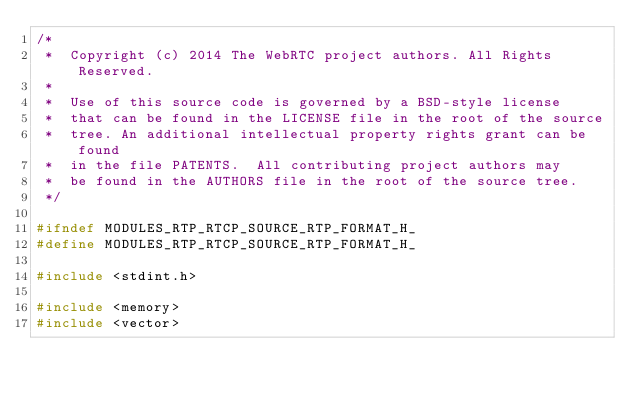<code> <loc_0><loc_0><loc_500><loc_500><_C_>/*
 *  Copyright (c) 2014 The WebRTC project authors. All Rights Reserved.
 *
 *  Use of this source code is governed by a BSD-style license
 *  that can be found in the LICENSE file in the root of the source
 *  tree. An additional intellectual property rights grant can be found
 *  in the file PATENTS.  All contributing project authors may
 *  be found in the AUTHORS file in the root of the source tree.
 */

#ifndef MODULES_RTP_RTCP_SOURCE_RTP_FORMAT_H_
#define MODULES_RTP_RTCP_SOURCE_RTP_FORMAT_H_

#include <stdint.h>

#include <memory>
#include <vector>
</code> 